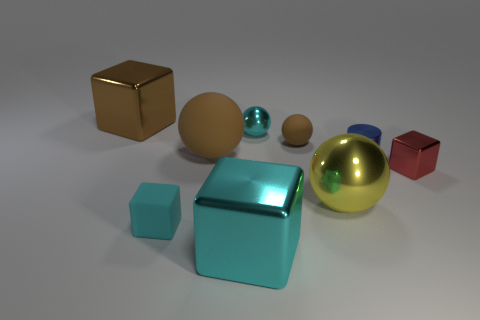Is the color of the large matte sphere the same as the small rubber sphere?
Give a very brief answer. Yes. What is the material of the large object that is the same color as the small metal sphere?
Provide a succinct answer. Metal. Is the number of tiny cyan rubber things less than the number of big things?
Your response must be concise. Yes. There is a small metallic object left of the shiny cylinder; does it have the same color as the small shiny block?
Provide a succinct answer. No. The small block that is the same material as the big brown sphere is what color?
Give a very brief answer. Cyan. Is the size of the metal cylinder the same as the yellow metal object?
Provide a succinct answer. No. What is the tiny blue thing made of?
Offer a very short reply. Metal. What material is the other block that is the same size as the cyan shiny cube?
Ensure brevity in your answer.  Metal. Are there any cyan things that have the same size as the blue cylinder?
Ensure brevity in your answer.  Yes. Is the number of brown matte objects that are in front of the small cyan block the same as the number of small rubber things to the left of the tiny brown rubber object?
Offer a terse response. No. 